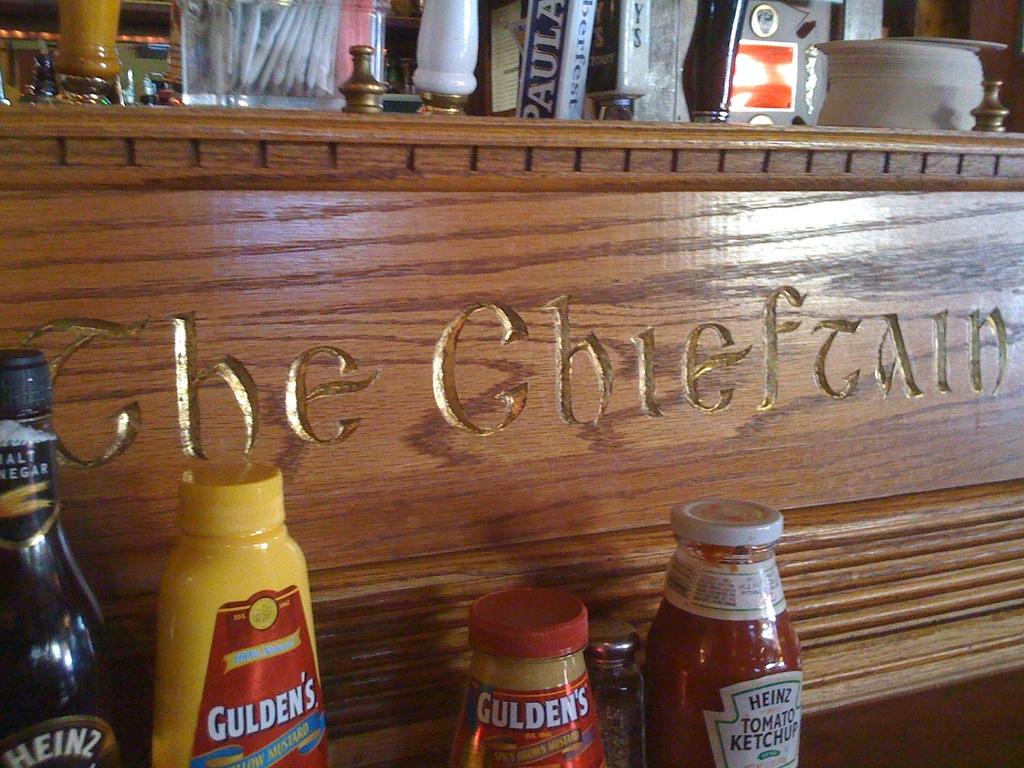What is the yellow bottle?
Your answer should be very brief. Gulden's. 